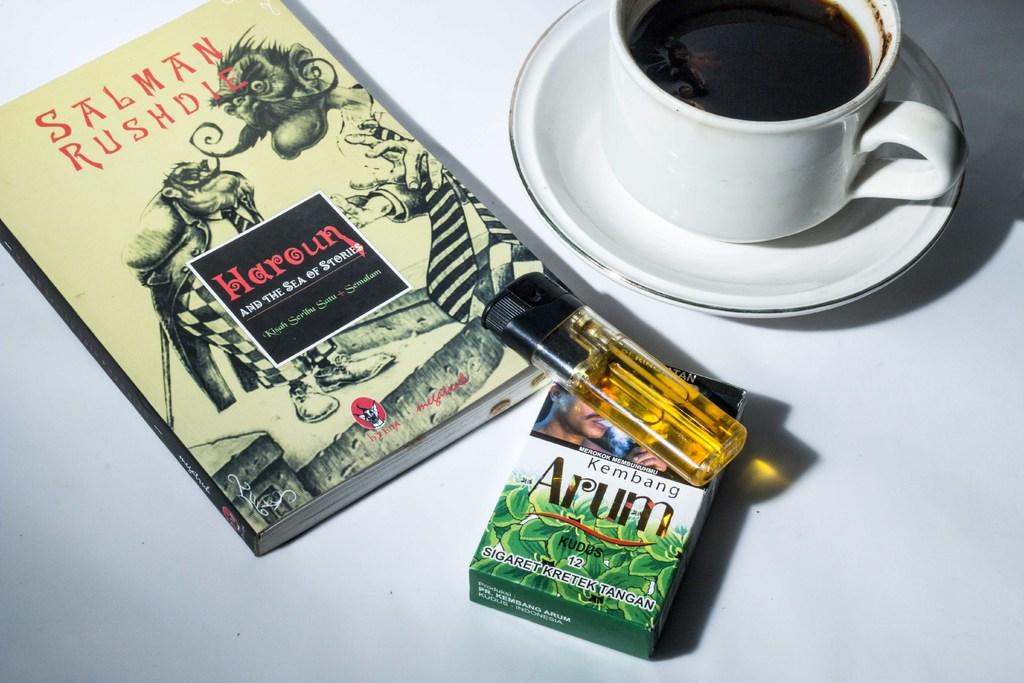Provide a one-sentence caption for the provided image. Pack of Arum with a lighter and a cup of coffee with a book. 